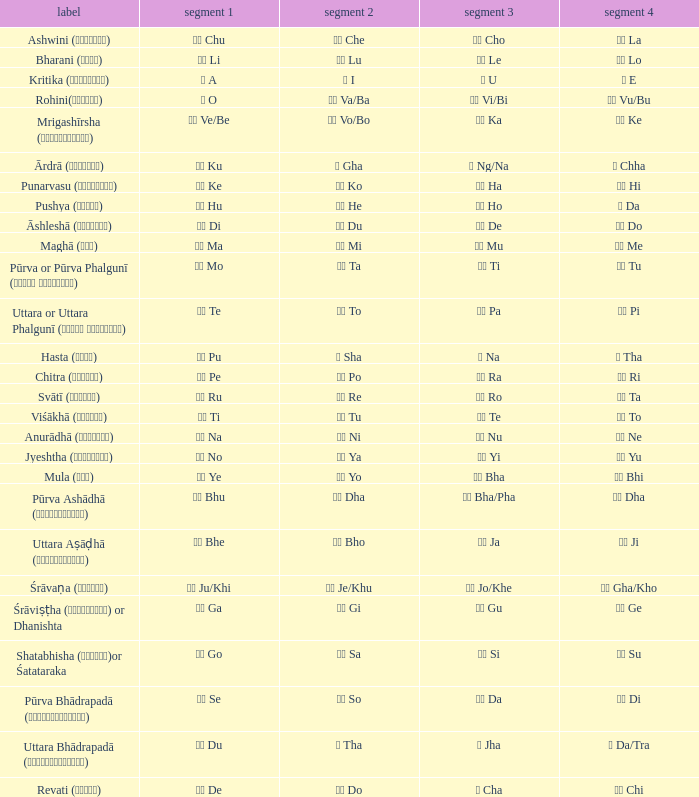Which pada 3 has a pada 2 of चे che? चो Cho. 